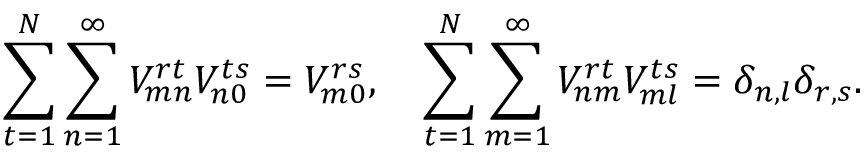Convert formula to latex. <formula><loc_0><loc_0><loc_500><loc_500>\sum _ { t = 1 } ^ { N } \sum _ { n = 1 } ^ { \infty } V _ { m n } ^ { r t } V _ { n 0 } ^ { t s } = V _ { m 0 } ^ { r s } , \quad s u m _ { t = 1 } ^ { N } \sum _ { m = 1 } ^ { \infty } V _ { n m } ^ { r t } V _ { m l } ^ { t s } = \delta _ { n , l } \delta _ { r , s } .</formula> 